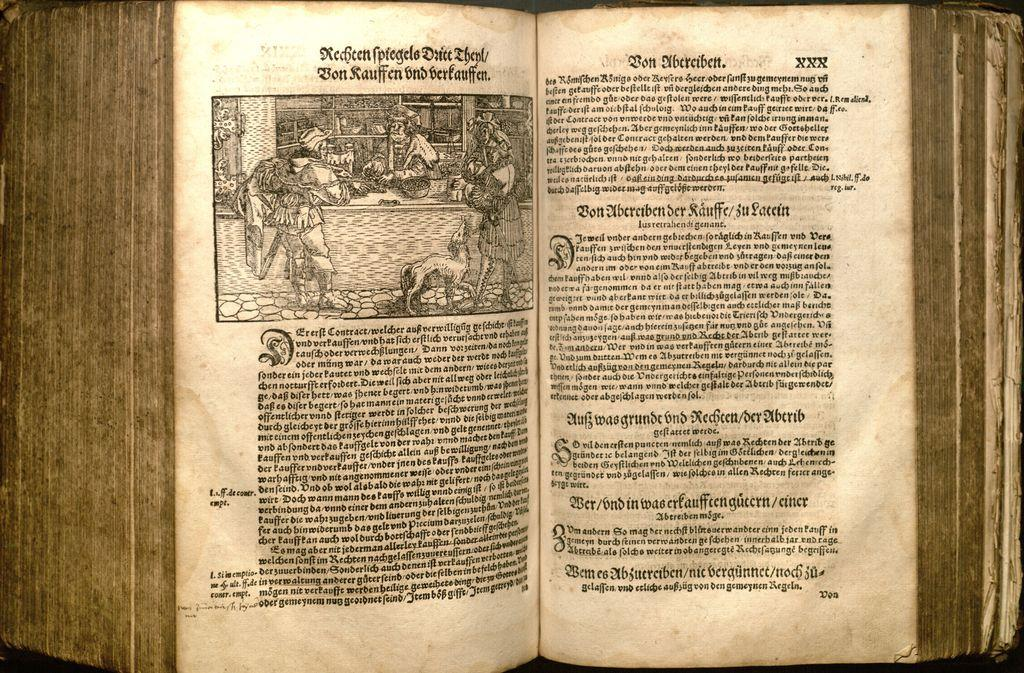What object is present in the image? There is a book in the image. What can be seen in the book? The book contains a picture of a group of people. Is there any text in the book? Yes, there is text written in the book. What type of punishment is being depicted in the book? There is no punishment being depicted in the book; it contains a picture of a group of people. What kind of records are being kept in the book? There are no records being kept in the book; it is a regular book with a picture and text. 